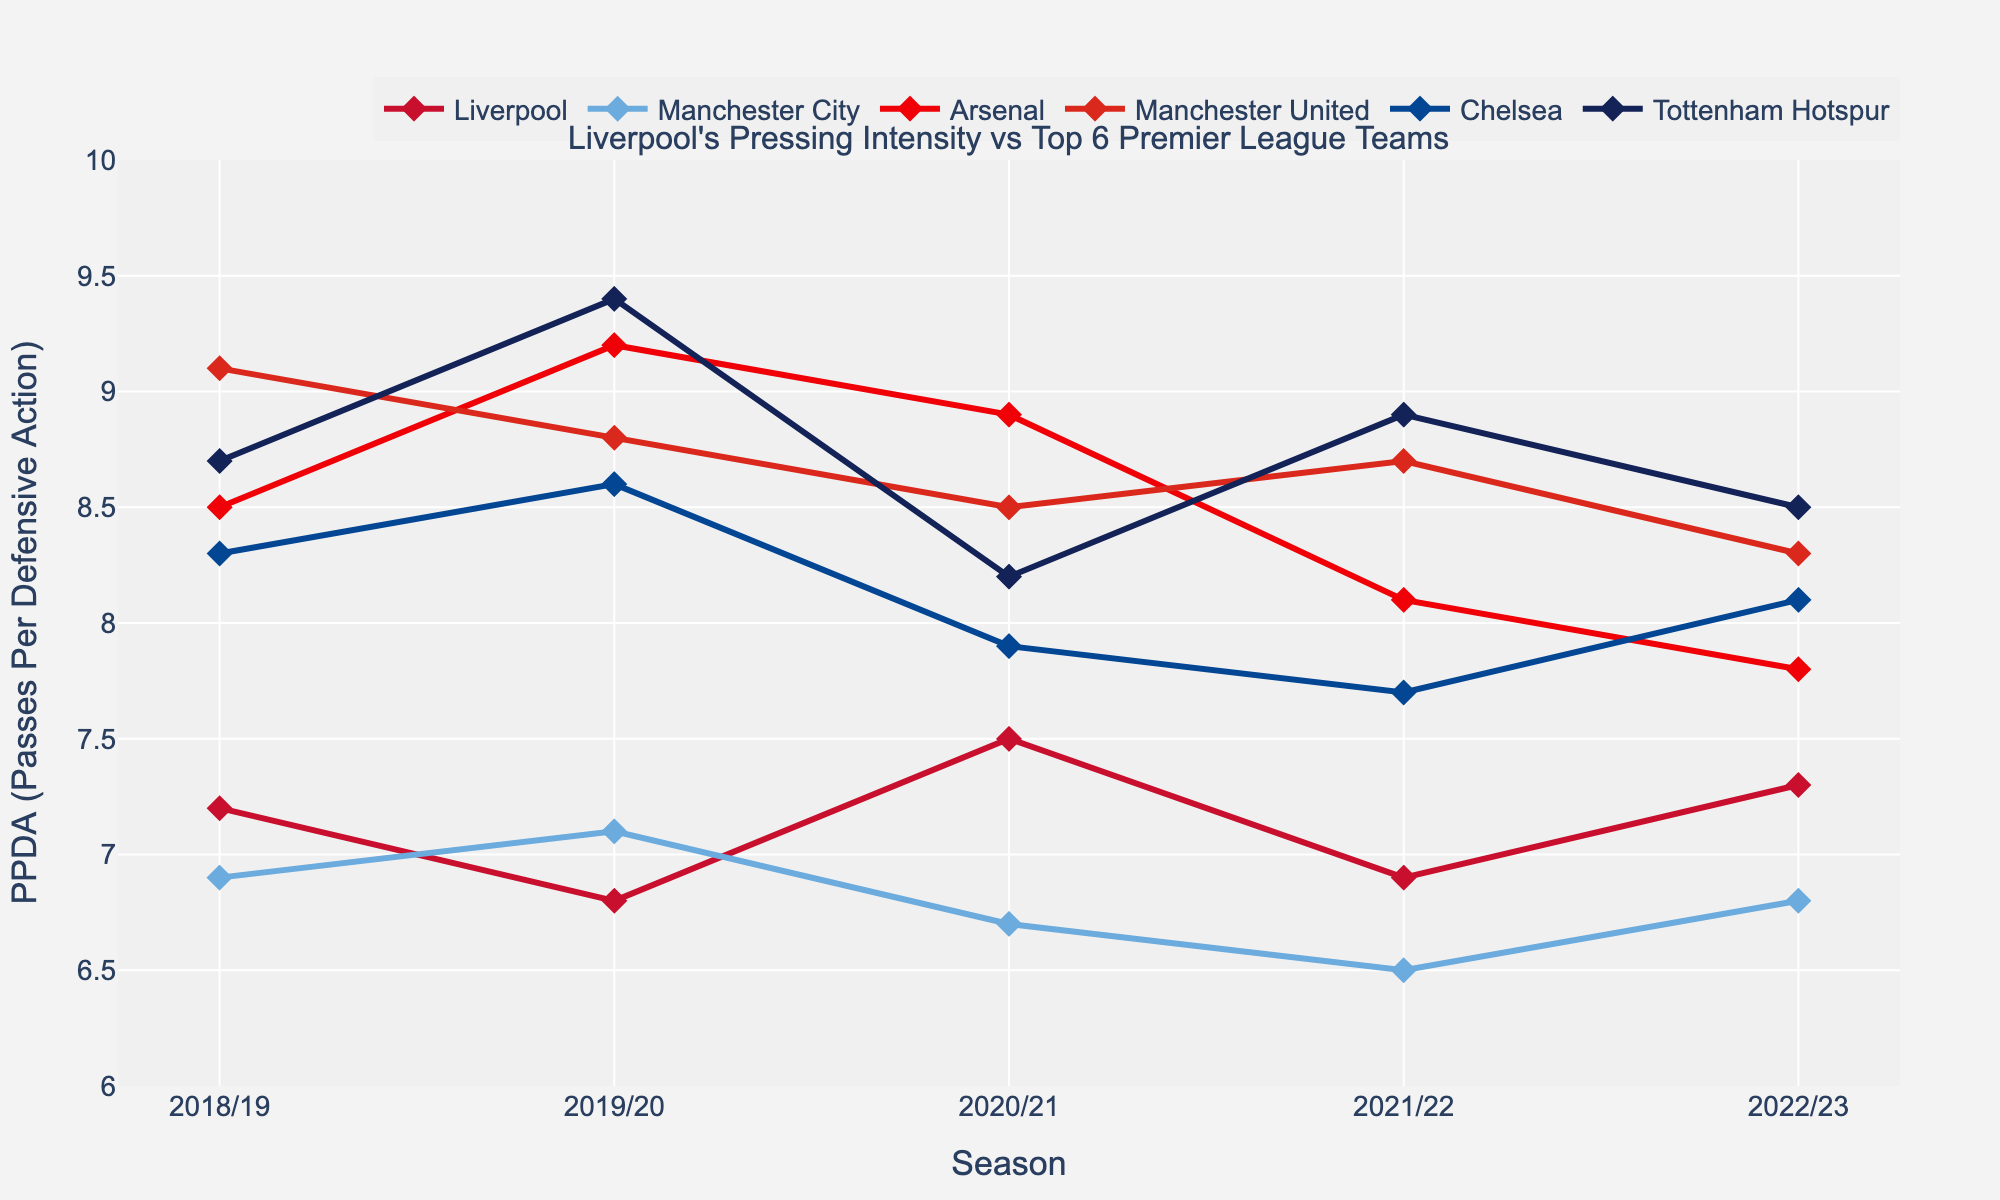What was Liverpool's highest PPDA value over the last 5 seasons? Review Liverpool's PPDA values for each season and identify the highest value. The values are 7.2, 6.8, 7.5, 6.9, 7.3. The highest value is 7.5.
Answer: 7.5 Which team had the lowest PPDA value in the 2020/21 season? Look at the PPDA values for each team in the 2020/21 season: Liverpool (7.5), Manchester City (6.7), Arsenal (8.9), Manchester United (8.5), Chelsea (7.9), Tottenham Hotspur (8.2). The lowest value is 6.7 by Manchester City.
Answer: Manchester City Compare Liverpool's PPDA value with Manchester United's PPDA value in the 2019/20 season. Which team had a higher value? In the 2019/20 season, Liverpool's PPDA is 6.8 and Manchester United's PPDA is 8.8. Liverpool's value is lower.
Answer: Manchester United How did Liverpool's PPDA value change from the 2018/19 season to the 2019/20 season? Liverpool's PPDA value in the 2018/19 season is 7.2, and in the 2019/20 season, it is 6.8. Calculate the difference: 7.2 - 6.8 = 0.4 decrease.
Answer: Decreased by 0.4 Which team showed the most significant improvement in PPDA from the 2021/22 season to the 2022/23 season? Compare each team's PPDA values in 2021/22 and 2022/23: Liverpool (6.9 to 7.3, +0.4), Manchester City (6.5 to 6.8, +0.3), Arsenal (8.1 to 7.8, -0.3), Manchester United (8.7 to 8.3, -0.4), Chelsea (7.7 to 8.1, +0.4), Tottenham Hotspur (8.9 to 8.5, -0.4). The most significant improvement is by Liverpool and Chelsea, both with a +0.4 increase.
Answer: Liverpool and Chelsea Calculate the average PPDA value for Liverpool over the last 5 seasons. Sum Liverpool's PPDA values over the last 5 seasons: 7.2 + 6.8 + 7.5 + 6.9 + 7.3 = 35.7. Divide by the number of seasons (5): 35.7 / 5 = 7.14.
Answer: 7.14 Between Arsenal and Tottenham Hotspur, which team consistently had higher PPDA values over the last 5 seasons? Compare the values season by season: 
2018/19: Arsenal (8.5), Tottenham (8.7) - Tottenham higher
2019/20: Arsenal (9.2), Tottenham (9.4) - Tottenham higher
2020/21: Arsenal (8.9), Tottenham (8.2) - Arsenal higher
2021/22: Arsenal (8.1), Tottenham (8.9) - Tottenham higher
2022/23: Arsenal (7.8), Tottenham (8.5) - Tottenham higher.
Tottenham had higher values in four out of five seasons.
Answer: Tottenham Hotspur What color is used to represent Liverpool in the chart? Observe the visual representation of Liverpool in the chart; Liverpool is depicted using the color red.
Answer: Red 